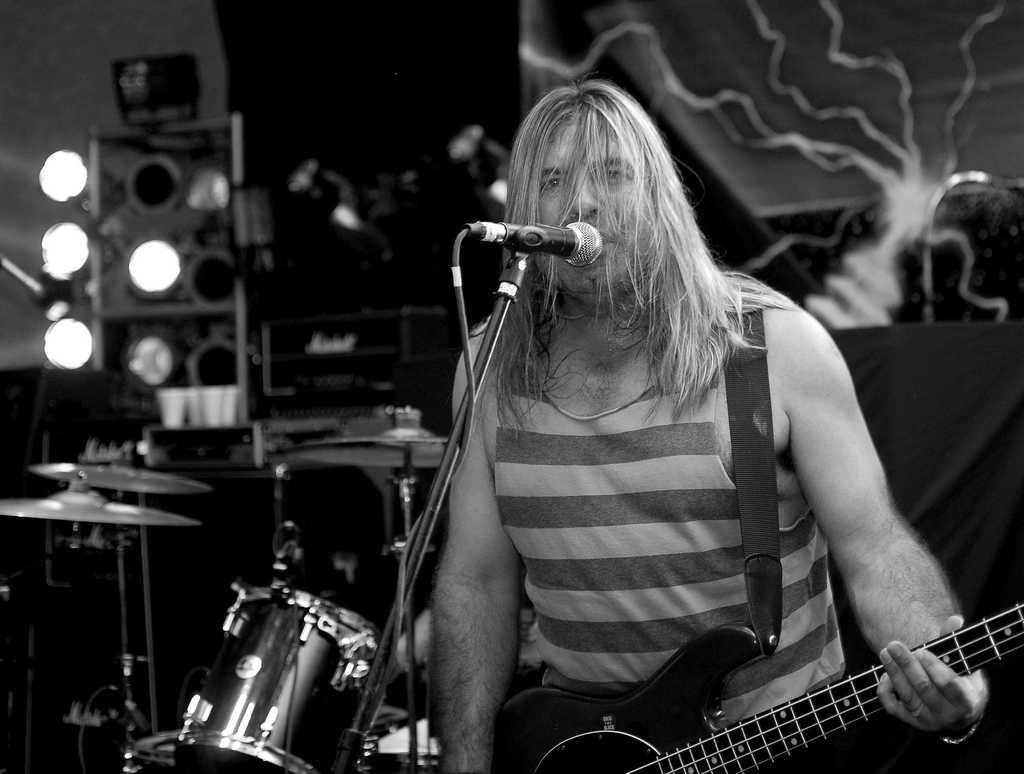What is the person in the image holding? The person is holding a guitar. What other musical instruments can be seen in the image? There are drums behind the person. What can be seen illuminating the scene in the image? There are lights visible in the image. What is at the front of the image for the person to use? There is a microphone at the front of the image, and it has a stand. Can you see a nest in the image? There is no nest present in the image. What is the purpose of the guitar in the image? The purpose of the guitar in the image is to be played by the person holding it, but we cannot determine the specific context or performance from the image alone. 